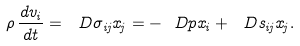Convert formula to latex. <formula><loc_0><loc_0><loc_500><loc_500>\rho \, \frac { d v _ { i } } { d t } = \ D { \sigma _ { i j } } { x _ { j } } = - \ D { p } { x _ { i } } + \ D { s _ { i j } } { x _ { j } } .</formula> 